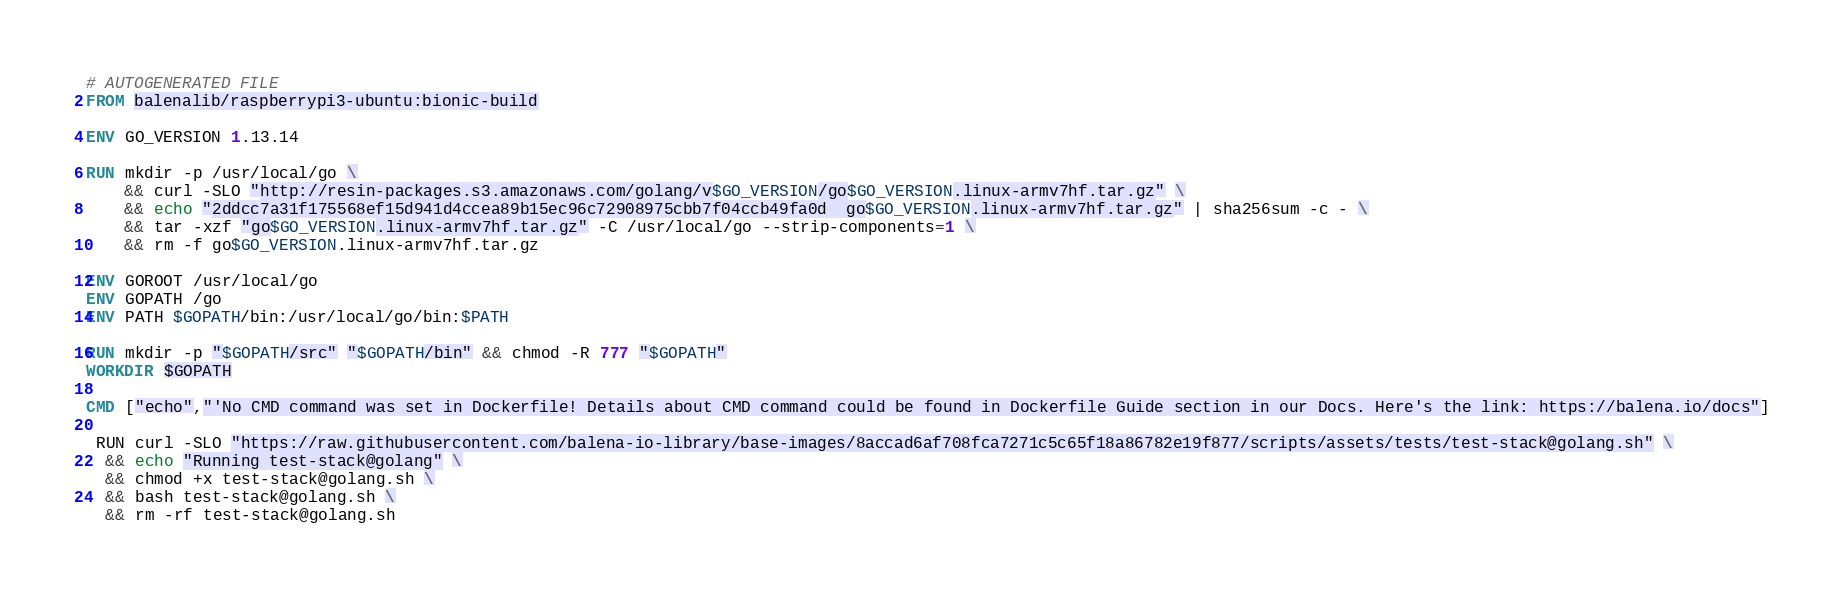Convert code to text. <code><loc_0><loc_0><loc_500><loc_500><_Dockerfile_># AUTOGENERATED FILE
FROM balenalib/raspberrypi3-ubuntu:bionic-build

ENV GO_VERSION 1.13.14

RUN mkdir -p /usr/local/go \
	&& curl -SLO "http://resin-packages.s3.amazonaws.com/golang/v$GO_VERSION/go$GO_VERSION.linux-armv7hf.tar.gz" \
	&& echo "2ddcc7a31f175568ef15d941d4ccea89b15ec96c72908975cbb7f04ccb49fa0d  go$GO_VERSION.linux-armv7hf.tar.gz" | sha256sum -c - \
	&& tar -xzf "go$GO_VERSION.linux-armv7hf.tar.gz" -C /usr/local/go --strip-components=1 \
	&& rm -f go$GO_VERSION.linux-armv7hf.tar.gz

ENV GOROOT /usr/local/go
ENV GOPATH /go
ENV PATH $GOPATH/bin:/usr/local/go/bin:$PATH

RUN mkdir -p "$GOPATH/src" "$GOPATH/bin" && chmod -R 777 "$GOPATH"
WORKDIR $GOPATH

CMD ["echo","'No CMD command was set in Dockerfile! Details about CMD command could be found in Dockerfile Guide section in our Docs. Here's the link: https://balena.io/docs"]

 RUN curl -SLO "https://raw.githubusercontent.com/balena-io-library/base-images/8accad6af708fca7271c5c65f18a86782e19f877/scripts/assets/tests/test-stack@golang.sh" \
  && echo "Running test-stack@golang" \
  && chmod +x test-stack@golang.sh \
  && bash test-stack@golang.sh \
  && rm -rf test-stack@golang.sh 
</code> 